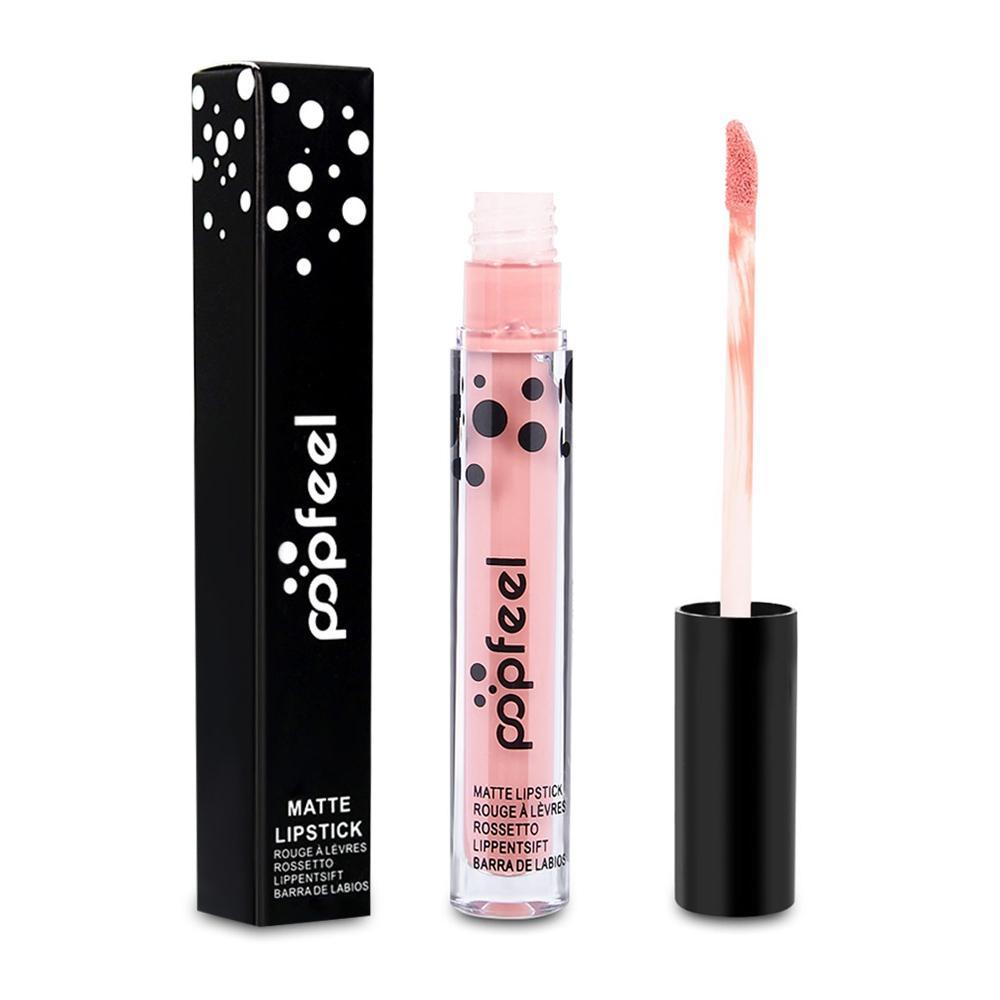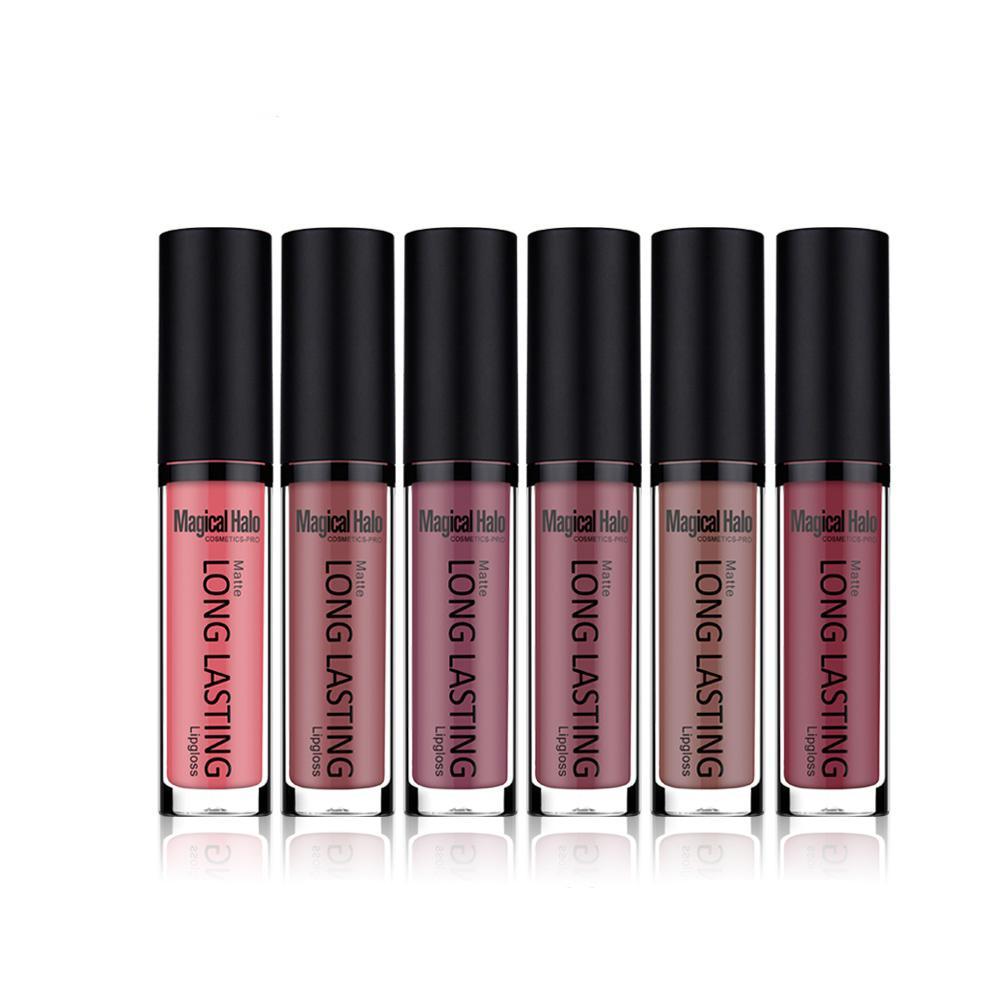The first image is the image on the left, the second image is the image on the right. Evaluate the accuracy of this statement regarding the images: "An image shows a row of three items, including a narrow box.". Is it true? Answer yes or no. Yes. 